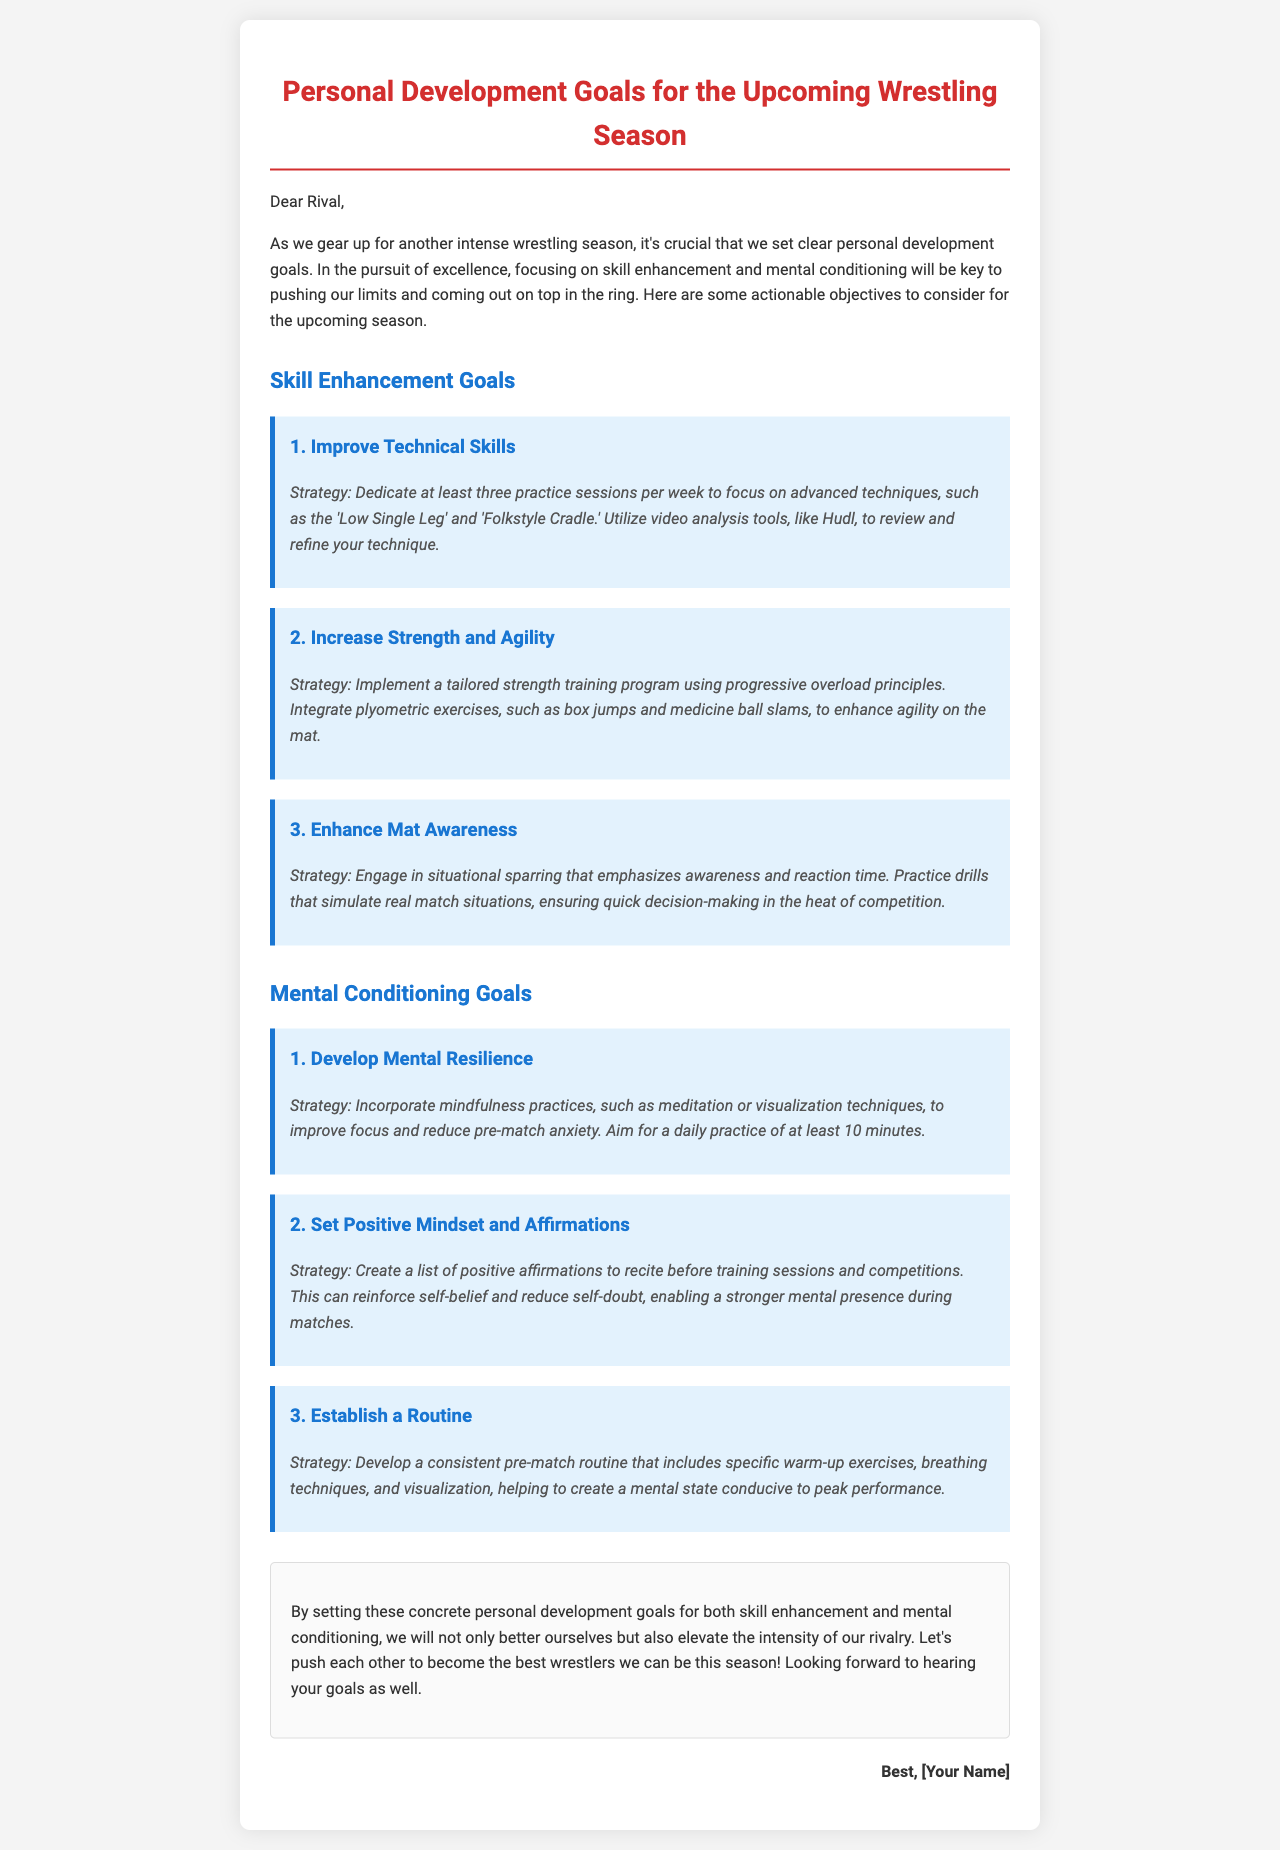What is the main focus of the document? The document emphasizes personal development goals in wrestling, particularly on skill enhancement and mental conditioning.
Answer: Personal development goals How many practice sessions per week are suggested for improving technical skills? The document specifies a recommendation of three practice sessions each week for technical skills improvement.
Answer: Three What are two advanced techniques mentioned for skill enhancement? The document lists 'Low Single Leg' and 'Folkstyle Cradle' as advanced techniques to focus on.
Answer: Low Single Leg, Folkstyle Cradle What mindfulness practices are suggested for developing mental resilience? The document recommends mindfulness practices such as meditation and visualization techniques.
Answer: Meditation, visualization techniques What is the required daily practice duration for mindfulness? The document suggests aiming for a daily mindfulness practice of at least 10 minutes.
Answer: 10 minutes What type of exercises are included in the routine suggested before matches? The document mentions specific warm-up exercises, breathing techniques, and visualization in the pre-match routine.
Answer: Warm-up exercises, breathing techniques, visualization What does the conclusion emphasize about the rivalry? The conclusion highlights that by setting goals, both wrestlers can elevate the intensity of their rivalry.
Answer: Elevate the intensity of our rivalry What is the color of the goal headings in the document? The goal headings in the document are colored blue (#1976d2).
Answer: Blue 